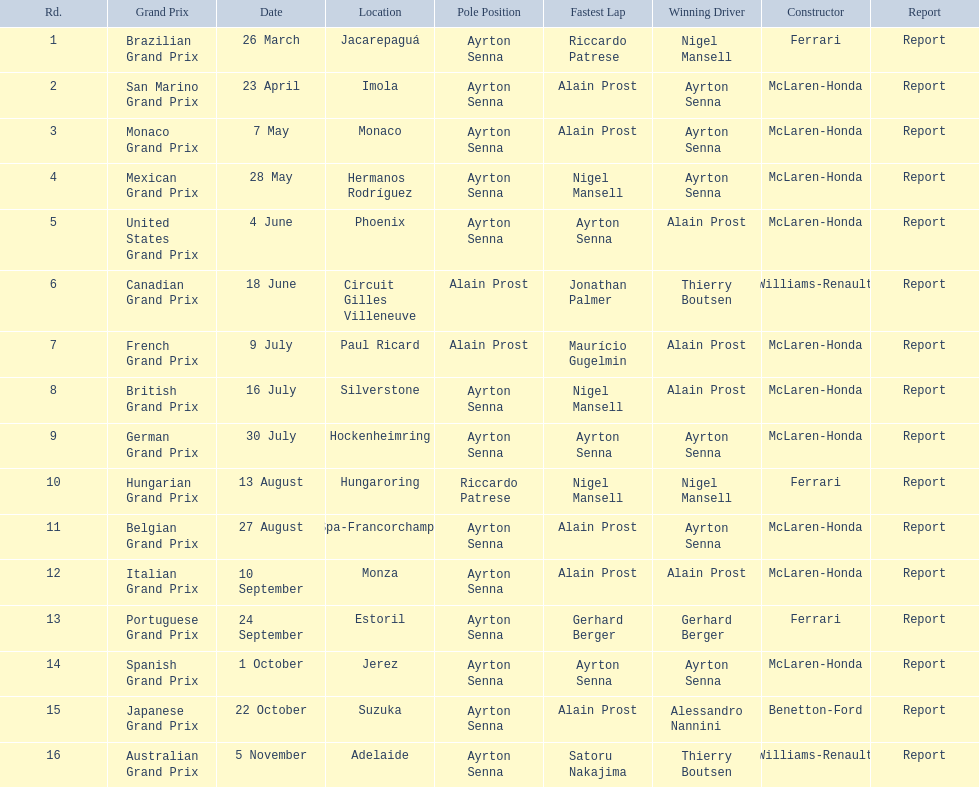During the 1989 formula one season, who were the participating constructors? Ferrari, McLaren-Honda, McLaren-Honda, McLaren-Honda, McLaren-Honda, Williams-Renault, McLaren-Honda, McLaren-Honda, McLaren-Honda, Ferrari, McLaren-Honda, McLaren-Honda, Ferrari, McLaren-Honda, Benetton-Ford, Williams-Renault. On which date was benetton ford acknowledged as the constructor? 22 October. What race occurred on the 22nd of october? Japanese Grand Prix. 